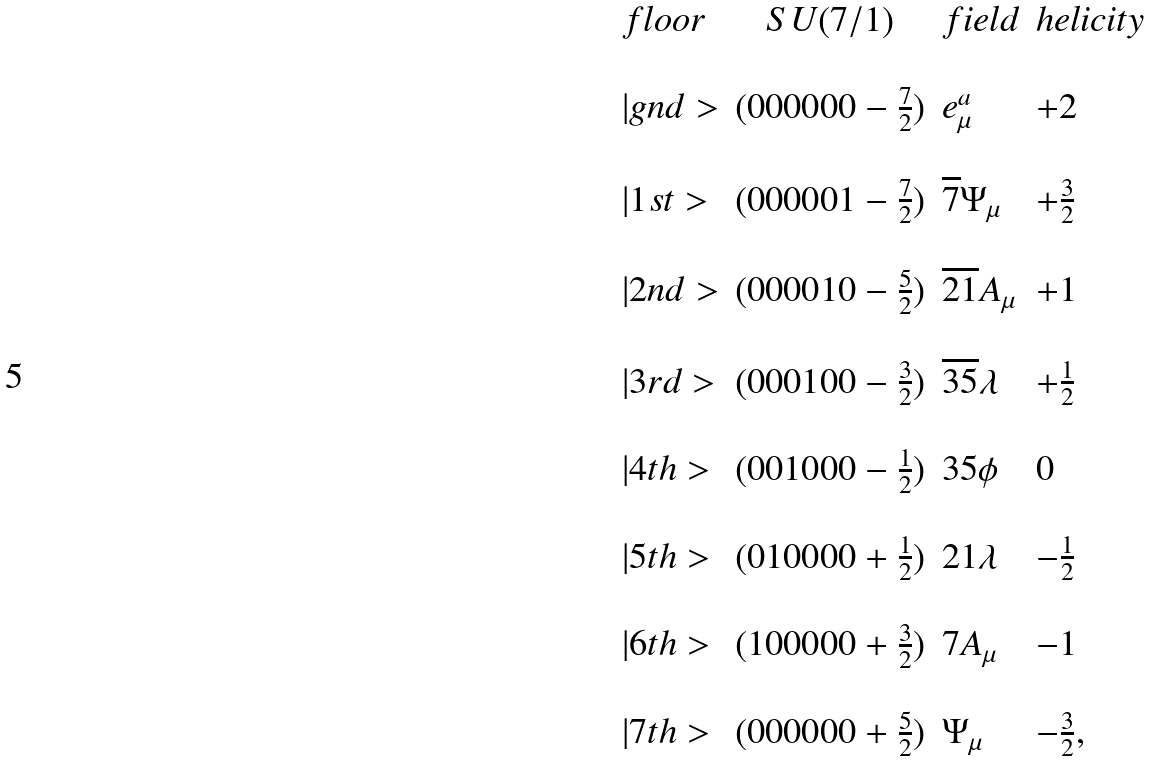Convert formula to latex. <formula><loc_0><loc_0><loc_500><loc_500>\begin{array} { l c l l } f l o o r & S U ( 7 / 1 ) & f i e l d & h e l i c i t y \\ \\ | g n d > & ( 0 0 0 0 0 0 - \frac { 7 } { 2 } ) & e _ { \mu } ^ { a } & + 2 \\ \\ | 1 s t > & ( 0 0 0 0 0 1 - \frac { 7 } { 2 } ) & \overline { 7 } \Psi _ { \mu } & + \frac { 3 } { 2 } \\ \\ | 2 n d > & ( 0 0 0 0 1 0 - \frac { 5 } { 2 } ) & \overline { 2 1 } A _ { \mu } & + 1 \\ \\ | 3 r d > & ( 0 0 0 1 0 0 - \frac { 3 } { 2 } ) & \overline { 3 5 } \lambda & + \frac { 1 } { 2 } \\ \\ | 4 t h > & ( 0 0 1 0 0 0 - \frac { 1 } { 2 } ) & 3 5 \phi & 0 \\ \\ | 5 t h > & ( 0 1 0 0 0 0 + \frac { 1 } { 2 } ) & 2 1 \lambda & - \frac { 1 } { 2 } \\ \\ | 6 t h > & ( 1 0 0 0 0 0 + \frac { 3 } { 2 } ) & 7 A _ { \mu } & - 1 \\ \\ | 7 t h > & ( 0 0 0 0 0 0 + \frac { 5 } { 2 } ) & \Psi _ { \mu } & - \frac { 3 } { 2 } , \\ \end{array}</formula> 